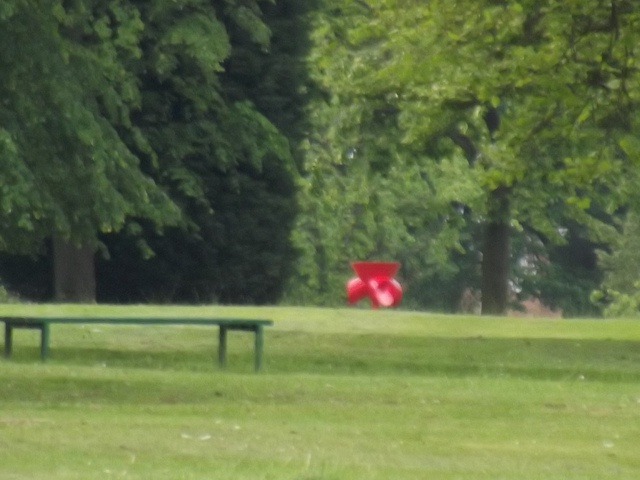Describe the objects in this image and their specific colors. I can see a bench in darkgreen, lightgreen, and olive tones in this image. 